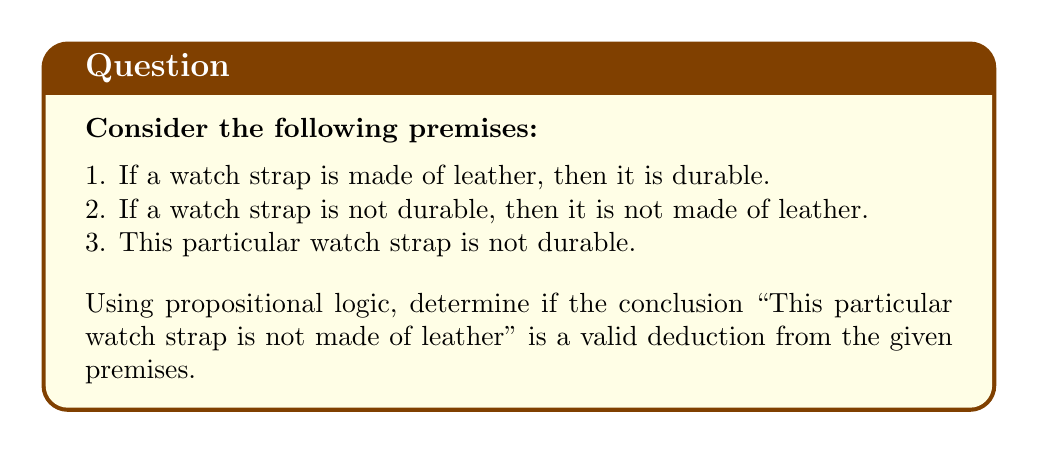Show me your answer to this math problem. Let's approach this step-by-step using propositional logic:

1. First, let's define our variables:
   $L$: The watch strap is made of leather
   $D$: The watch strap is durable

2. Now, let's translate the premises into logical statements:
   Premise 1: $L \rightarrow D$
   Premise 2: $\neg D \rightarrow \neg L$
   Premise 3: $\neg D$

3. The conclusion we're testing is: $\neg L$

4. To prove this is a valid deduction, we can use the method of modus ponens:
   
   a) From Premise 3 ($\neg D$) and Premise 2 ($\neg D \rightarrow \neg L$), we can directly apply modus ponens:
      $$\frac{\neg D, \quad \neg D \rightarrow \neg L}{\therefore \neg L}$$

5. Alternatively, we can also prove this using the contrapositive:
   
   a) The contrapositive of Premise 1 ($L \rightarrow D$) is ($\neg D \rightarrow \neg L$), which is exactly Premise 2.
   
   b) Then, using Premise 3 ($\neg D$) and the contrapositive ($\neg D \rightarrow \neg L$), we can again apply modus ponens to arrive at $\neg L$.

6. Both methods lead to the same conclusion: $\neg L$, which matches our desired conclusion.

Therefore, the conclusion "This particular watch strap is not made of leather" is indeed a valid deduction from the given premises.
Answer: The conclusion is valid. The deduction "This particular watch strap is not made of leather" ($\neg L$) follows logically from the given premises using modus ponens or the contrapositive method. 